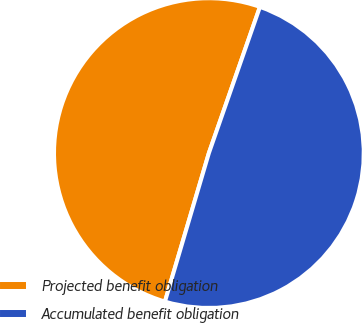Convert chart to OTSL. <chart><loc_0><loc_0><loc_500><loc_500><pie_chart><fcel>Projected benefit obligation<fcel>Accumulated benefit obligation<nl><fcel>50.77%<fcel>49.23%<nl></chart> 